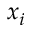<formula> <loc_0><loc_0><loc_500><loc_500>x _ { i }</formula> 